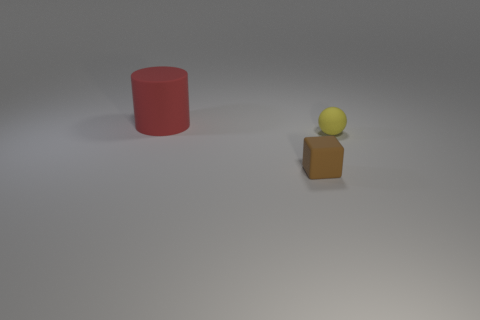What number of things are small blue matte blocks or objects that are right of the small matte cube?
Give a very brief answer. 1. What is the size of the matte object that is both to the left of the yellow ball and behind the small brown rubber cube?
Make the answer very short. Large. There is a big red cylinder; are there any tiny brown matte things to the right of it?
Offer a terse response. Yes. Is there a yellow matte object that is on the right side of the tiny thing to the left of the tiny yellow matte sphere?
Give a very brief answer. Yes. Are there the same number of small brown rubber cubes that are behind the tiny yellow rubber sphere and big objects to the right of the brown matte thing?
Offer a terse response. Yes. What color is the small ball that is made of the same material as the red cylinder?
Your answer should be compact. Yellow. Is there a yellow object made of the same material as the small brown cube?
Offer a terse response. Yes. What number of things are yellow objects or purple shiny things?
Your response must be concise. 1. There is a matte object to the left of the brown rubber cube; what size is it?
Ensure brevity in your answer.  Large. Are there fewer large things than large cyan metallic objects?
Make the answer very short. No. 